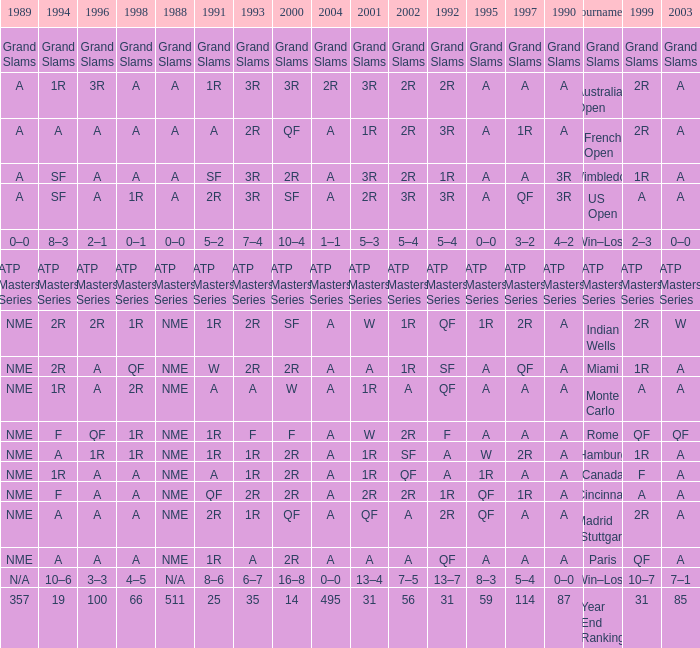What shows for 202 when the 1994 is A, the 1989 is NME, and the 199 is 2R? A. 